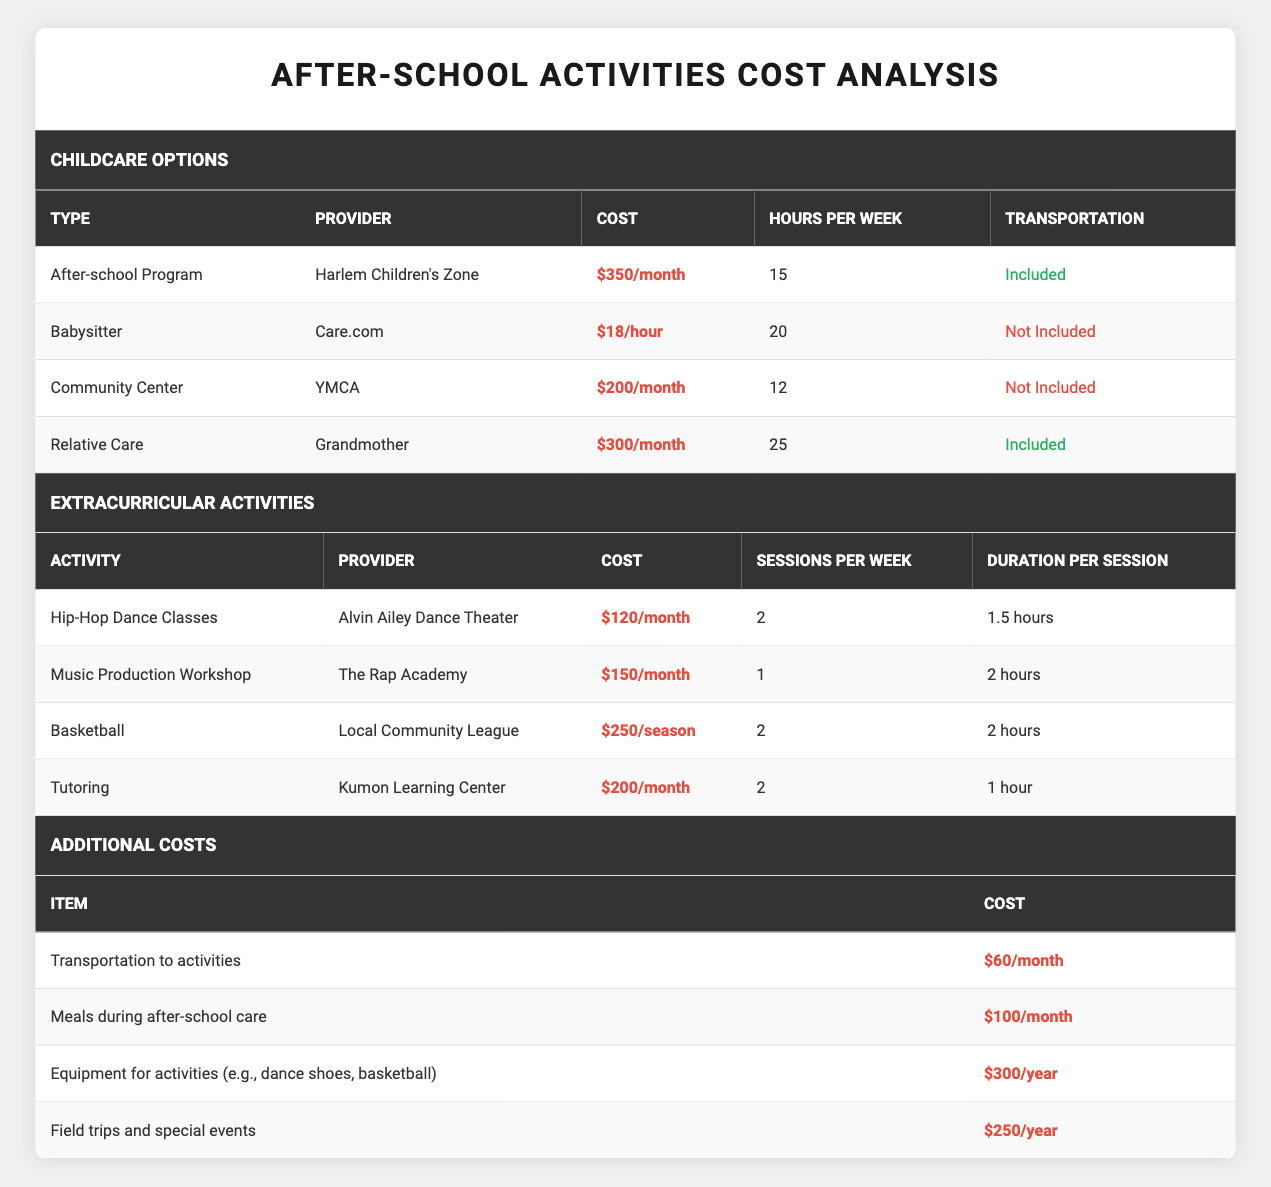What is the monthly cost of the After-school Program at Harlem Children's Zone? The table lists the After-school Program under childcare options, and it states the cost is $350/month.
Answer: $350/month How many hours per week does the Relative Care option provide? Looking under the childcare options, the Relative Care option (provided by Grandmother) is listed with hours per week being 25.
Answer: 25 hours What is the total monthly cost for the Hip-Hop Dance Classes and the Music Production Workshop combined? The Hip-Hop Dance Classes cost $120/month and the Music Production Workshop costs $150/month. Adding these costs together gives $120 + $150 = $270/month.
Answer: $270/month Is transportation included in the Community Center option? The table indicates that transportation is not included in the Community Center option offered by YMCA, as shown in the transportation column.
Answer: No What is the total cost per month if I choose the YMCA Community Center and bring meals during after-school care? The YMCA Community Center costs $200/month, and meals during after-school care cost an additional $100/month. Summing both costs gives $200 + $100 = $300/month.
Answer: $300/month Which option has the most hours of care per week? Scanning through the childcare options, Relative Care gives the highest number of hours per week, which is 25 hours.
Answer: Relative Care What is the annual cost of equipment for activities like dance shoes and basketball? The table lists equipment for activities with a cost of $300/year. This is found in the additional costs section.
Answer: $300/year If I choose the Babysitter option, how much would it cost for 4 weeks? The Babysitter option costs $18/hour, and with 20 hours per week, it becomes $18 x 20 = $360/week. Multiplying by 4 weeks gives $360 x 4 = $1440.
Answer: $1440 How much would I spend on transportation to activities in a year? The transportation cost to activities is $60/month. To find the total for a year, multiply $60 by 12 (months), resulting in $720/year.
Answer: $720/year 